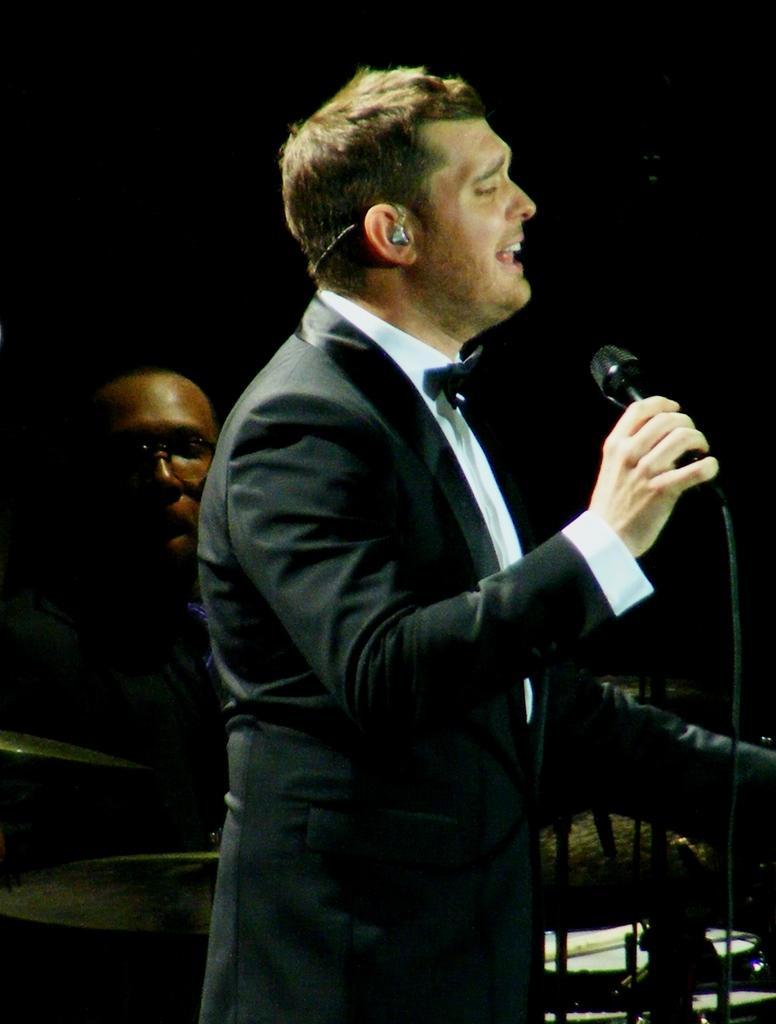Could you give a brief overview of what you see in this image? In this picture we can see two people, a man is singing with the help of microphone and another one is playing drums. 